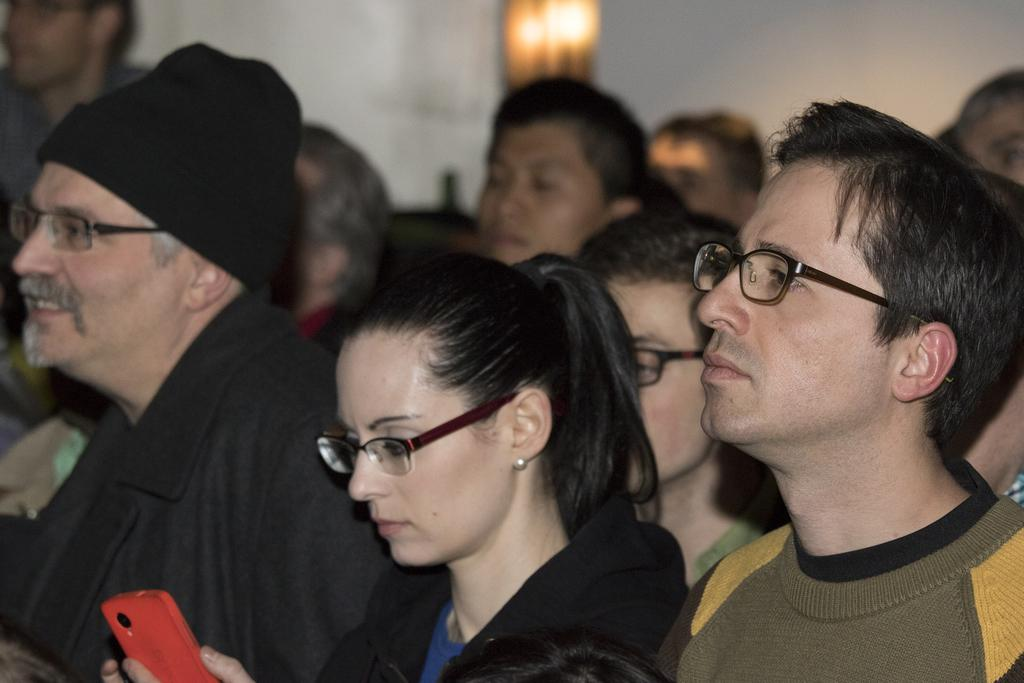How many people are in the image? There are people in the image, but the exact number is not specified. What can be observed about some of the people in the image? Some of the people in the image are wearing spectacles. What type of grain is being harvested in the image? There is no reference to grain or any harvesting activity in the image. 